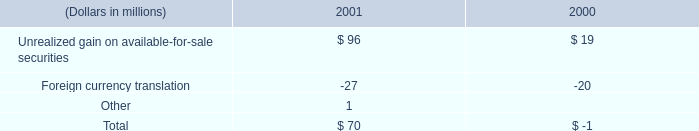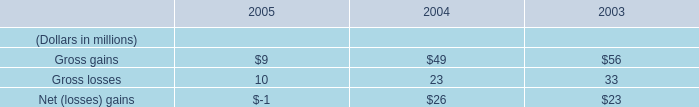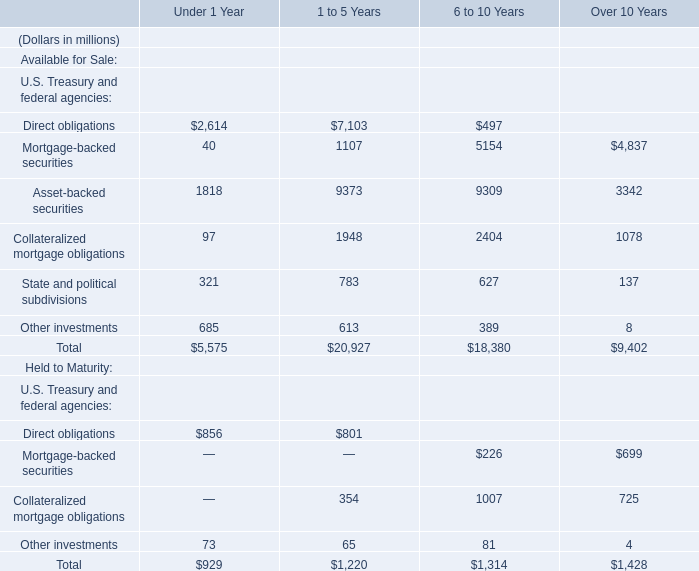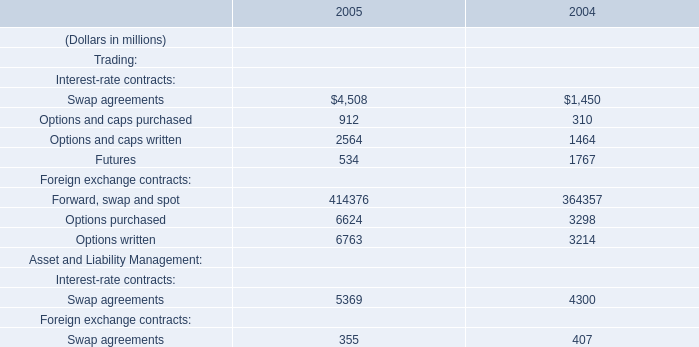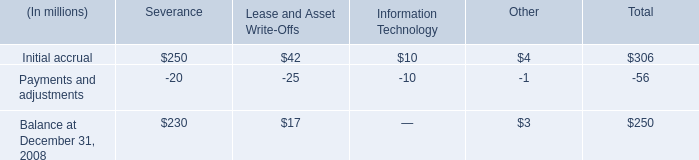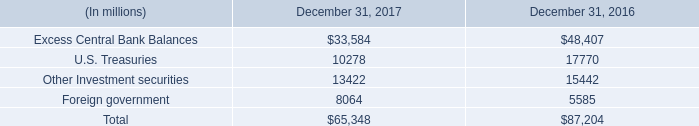what value of cad is equal to $ 1 usd? 
Computations: (800 / 657)
Answer: 1.21766. 